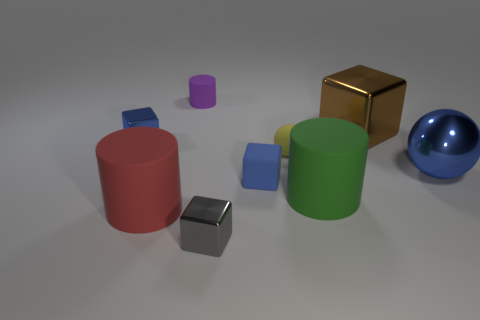Add 1 cubes. How many objects exist? 10 Subtract all cubes. How many objects are left? 5 Add 9 brown metallic objects. How many brown metallic objects are left? 10 Add 4 purple rubber things. How many purple rubber things exist? 5 Subtract 1 red cylinders. How many objects are left? 8 Subtract all small gray metallic cubes. Subtract all small blue cubes. How many objects are left? 6 